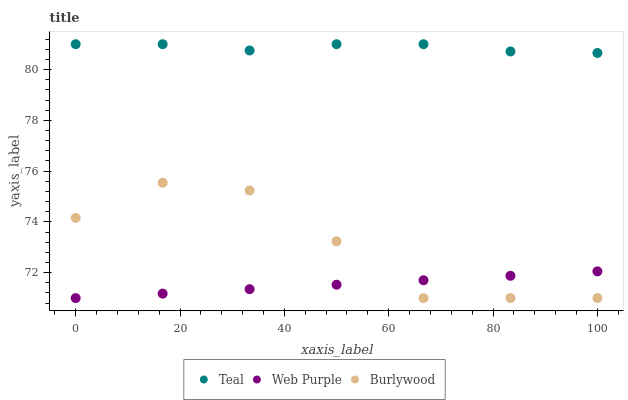Does Web Purple have the minimum area under the curve?
Answer yes or no. Yes. Does Teal have the maximum area under the curve?
Answer yes or no. Yes. Does Teal have the minimum area under the curve?
Answer yes or no. No. Does Web Purple have the maximum area under the curve?
Answer yes or no. No. Is Web Purple the smoothest?
Answer yes or no. Yes. Is Burlywood the roughest?
Answer yes or no. Yes. Is Teal the smoothest?
Answer yes or no. No. Is Teal the roughest?
Answer yes or no. No. Does Burlywood have the lowest value?
Answer yes or no. Yes. Does Teal have the lowest value?
Answer yes or no. No. Does Teal have the highest value?
Answer yes or no. Yes. Does Web Purple have the highest value?
Answer yes or no. No. Is Burlywood less than Teal?
Answer yes or no. Yes. Is Teal greater than Web Purple?
Answer yes or no. Yes. Does Web Purple intersect Burlywood?
Answer yes or no. Yes. Is Web Purple less than Burlywood?
Answer yes or no. No. Is Web Purple greater than Burlywood?
Answer yes or no. No. Does Burlywood intersect Teal?
Answer yes or no. No. 